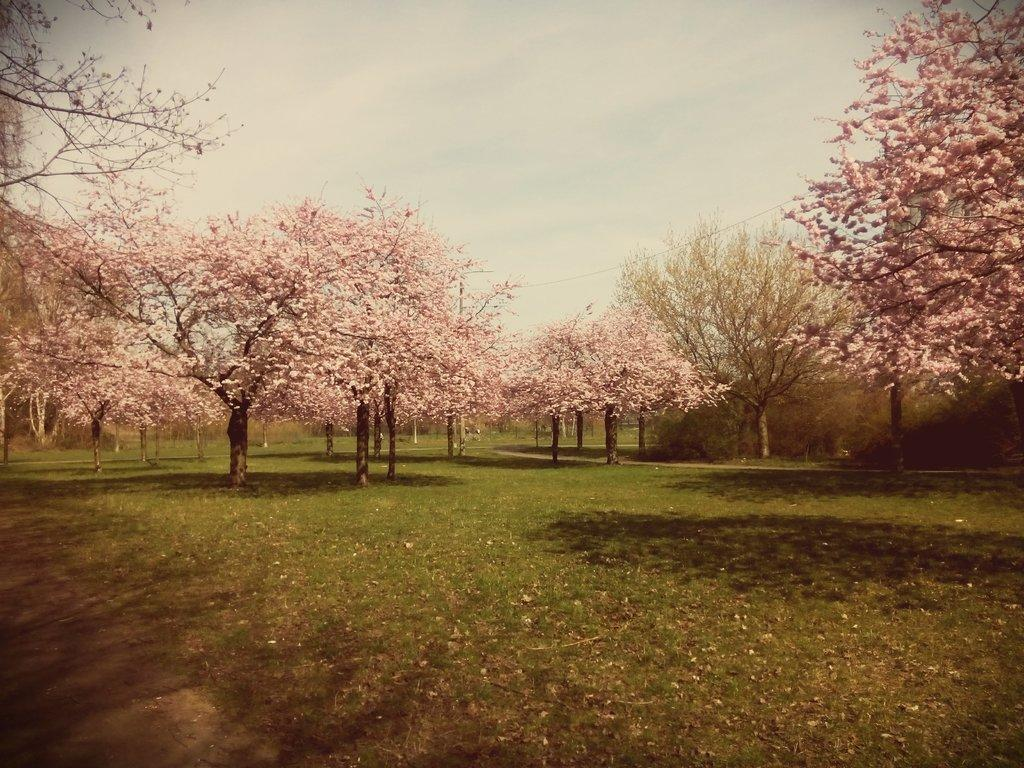What type of vegetation is present in the image? There are trees in the image. What is special about the trees in the image? The trees have blossoms. What is at the bottom of the image? There is grass at the bottom of the image. What can be seen in the distance in the image? The sky is visible in the background of the image. What song is being sung by the trees in the image? There is no indication in the image that the trees are singing a song. 